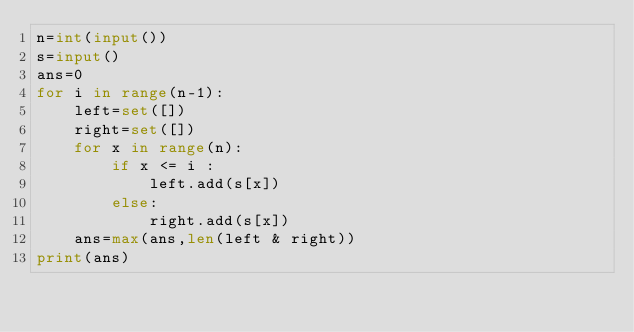Convert code to text. <code><loc_0><loc_0><loc_500><loc_500><_Python_>n=int(input())
s=input()
ans=0
for i in range(n-1):
    left=set([])
    right=set([])
    for x in range(n):
        if x <= i :
            left.add(s[x])
        else:
            right.add(s[x])
    ans=max(ans,len(left & right))
print(ans)</code> 